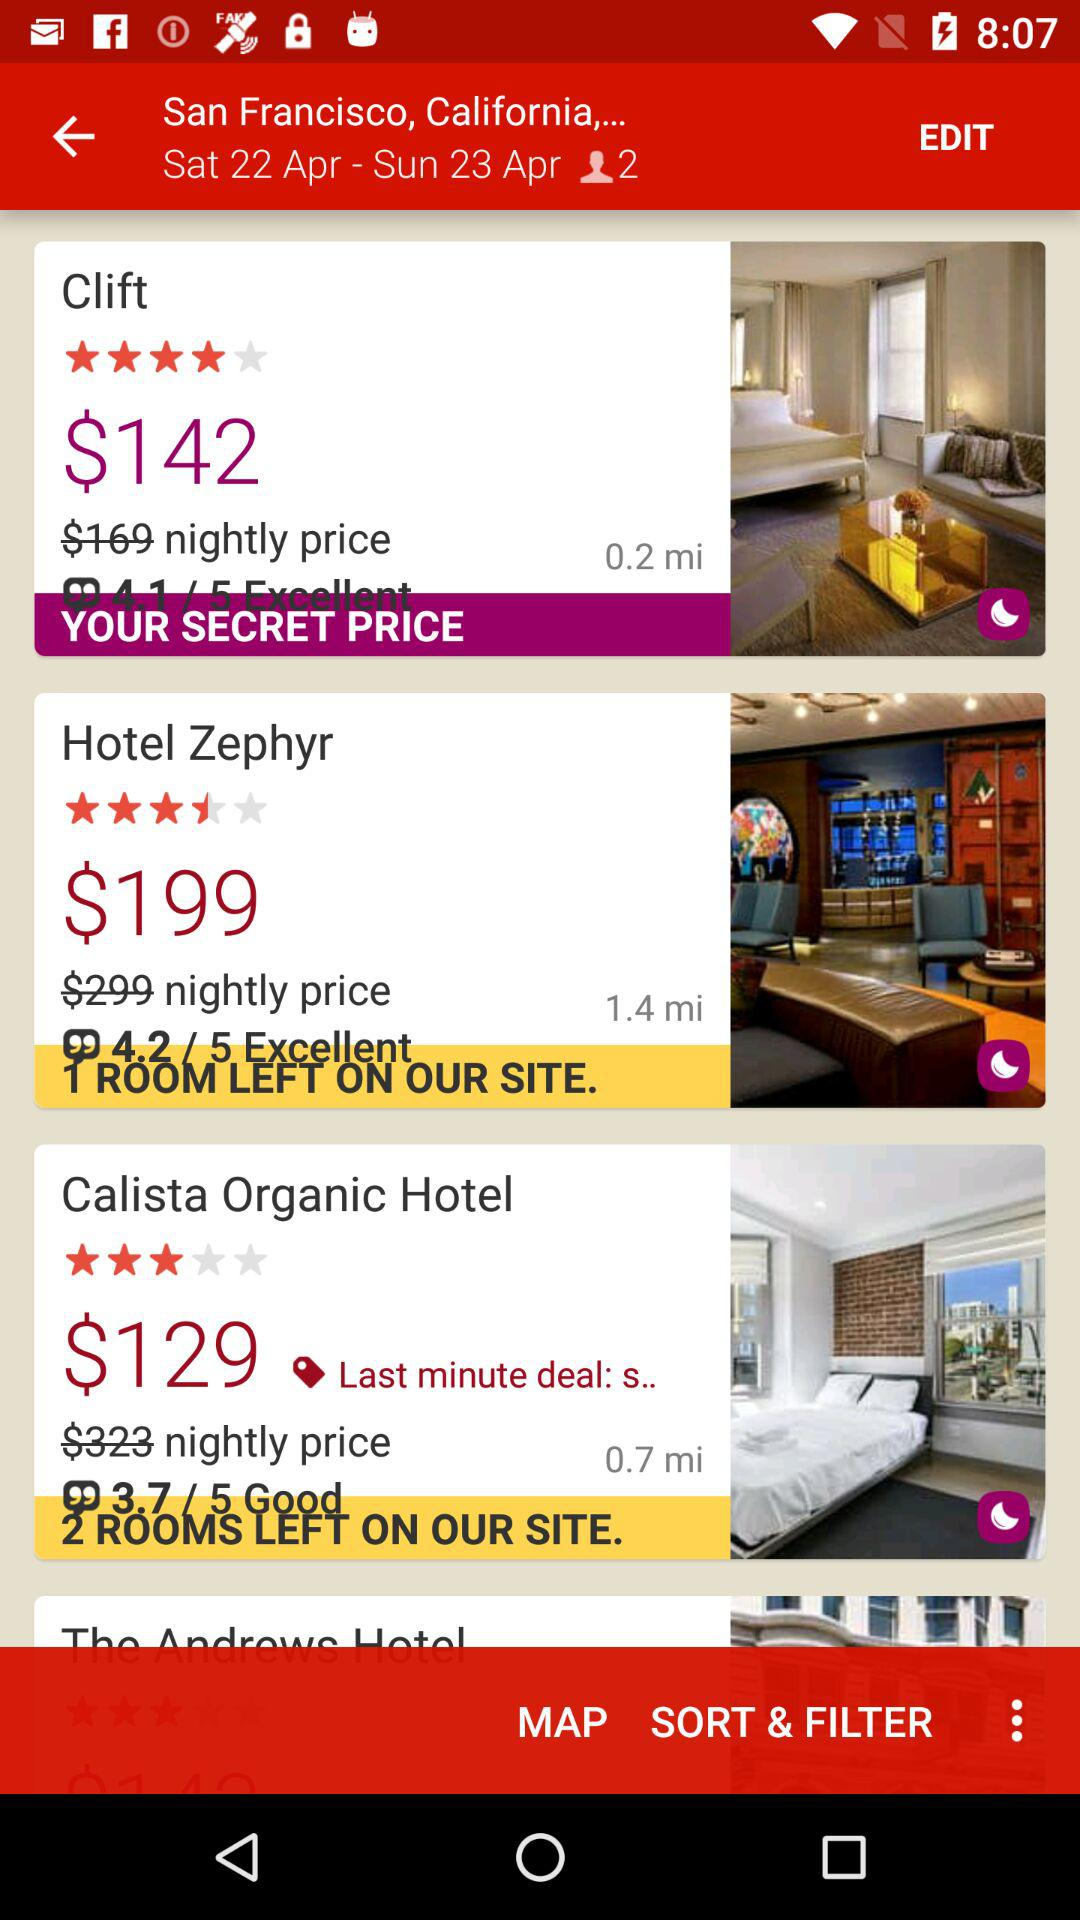What hotels have "Last minute deal: s"? The name of the hotel is "Calista Organic". 